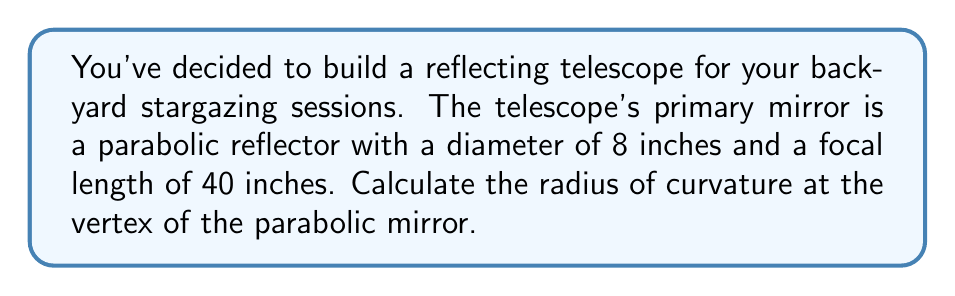Give your solution to this math problem. To solve this problem, we'll follow these steps:

1) The shape of a parabolic mirror can be described by the equation:

   $$y = \frac{x^2}{4f}$$

   where $f$ is the focal length and $x$ and $y$ are coordinates on the mirror's surface.

2) The radius of curvature at the vertex of a parabola is given by the formula:

   $$R = 2f$$

   where $R$ is the radius of curvature and $f$ is the focal length.

3) We're given that the focal length is 40 inches. Let's substitute this into our formula:

   $$R = 2 * 40$$

4) Now we can calculate:

   $$R = 80\text{ inches}$$

To visualize this, we can draw a diagram of the mirror:

[asy]
import geometry;

size(200);

real f = 40;
real d = 8;

path mirror = graph(new pair(real x){return (x, x^2/(4f));}, -d/2, d/2);
draw(mirror, blue);

dot((0,0), red);
label("Vertex", (0,0), S);

draw((0,0)--(0,f), dashed);
dot((0,f), red);
label("Focal point", (0,f), E);

draw((-d/2,0)--(d/2,0), black);
label("Diameter = 8\"", (0,0), N);

label("Focal length = 40\"", (0,f/2), E);

draw(arc((0,R), R, -10, 10), red);
label("R = 80\"", (R/2,R/2), NE);
[/asy]

This diagram shows the parabolic mirror with its focal point, vertex, and radius of curvature. The mirror's shape is exaggerated for clarity.
Answer: The radius of curvature at the vertex of the parabolic mirror is 80 inches. 